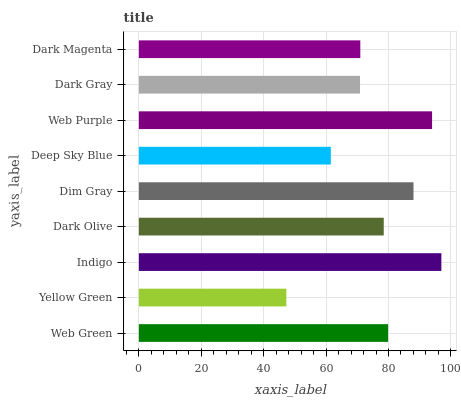Is Yellow Green the minimum?
Answer yes or no. Yes. Is Indigo the maximum?
Answer yes or no. Yes. Is Indigo the minimum?
Answer yes or no. No. Is Yellow Green the maximum?
Answer yes or no. No. Is Indigo greater than Yellow Green?
Answer yes or no. Yes. Is Yellow Green less than Indigo?
Answer yes or no. Yes. Is Yellow Green greater than Indigo?
Answer yes or no. No. Is Indigo less than Yellow Green?
Answer yes or no. No. Is Dark Olive the high median?
Answer yes or no. Yes. Is Dark Olive the low median?
Answer yes or no. Yes. Is Dark Gray the high median?
Answer yes or no. No. Is Dark Gray the low median?
Answer yes or no. No. 